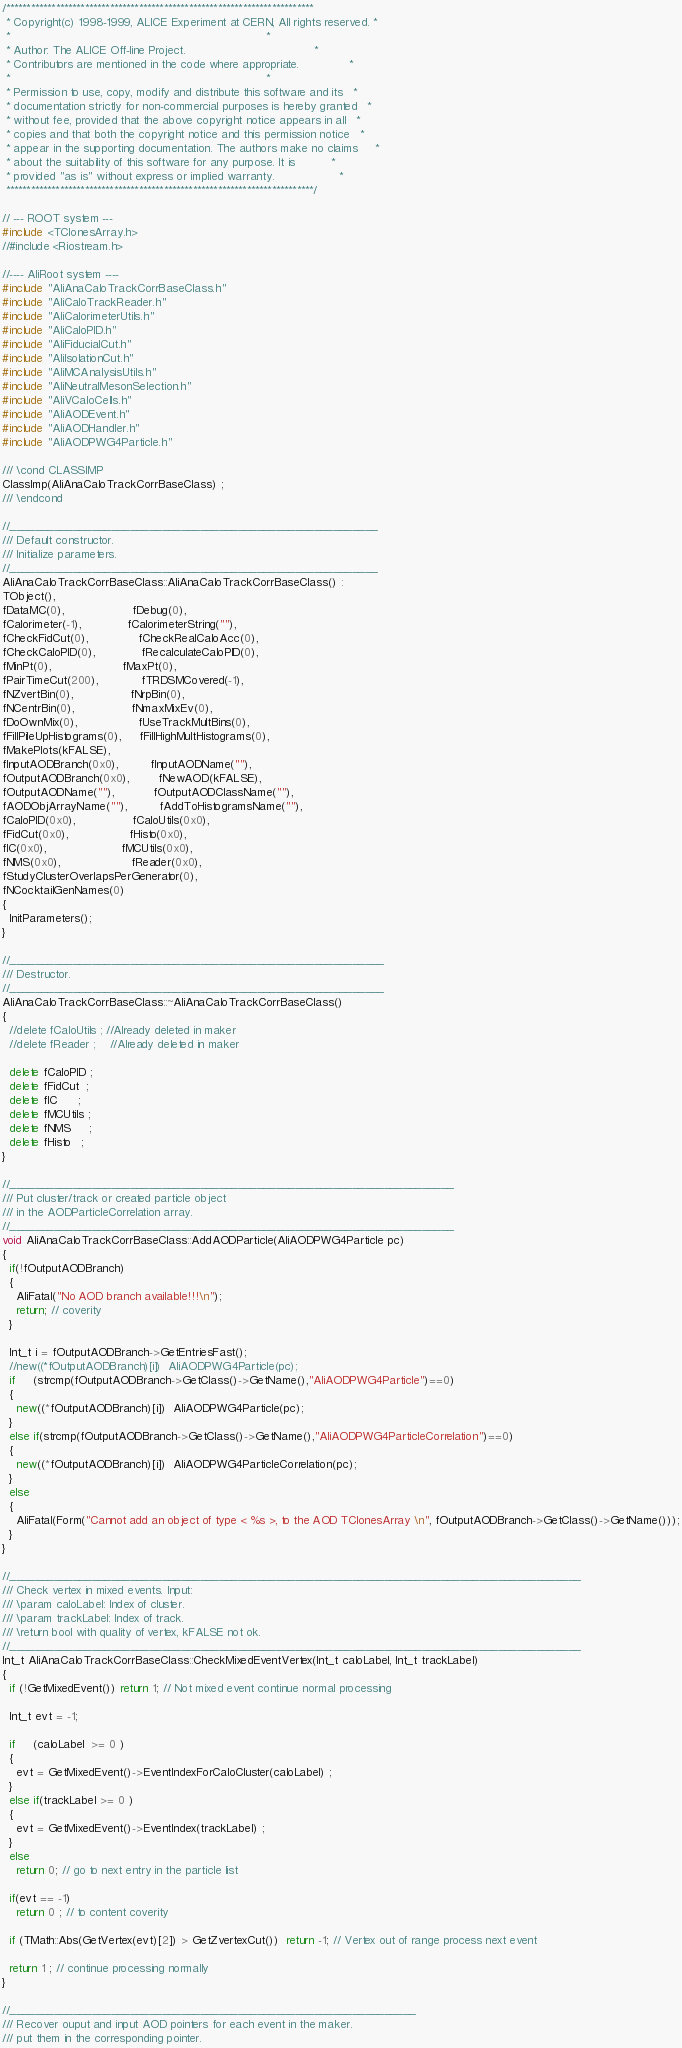Convert code to text. <code><loc_0><loc_0><loc_500><loc_500><_C++_>/**************************************************************************
 * Copyright(c) 1998-1999, ALICE Experiment at CERN, All rights reserved. *
 *                                                                        *
 * Author: The ALICE Off-line Project.                                    *
 * Contributors are mentioned in the code where appropriate.              *
 *                                                                        *
 * Permission to use, copy, modify and distribute this software and its   *
 * documentation strictly for non-commercial purposes is hereby granted   *
 * without fee, provided that the above copyright notice appears in all   *
 * copies and that both the copyright notice and this permission notice   *
 * appear in the supporting documentation. The authors make no claims     *
 * about the suitability of this software for any purpose. It is          *
 * provided "as is" without express or implied warranty.                  *
 **************************************************************************/

// --- ROOT system ---
#include <TClonesArray.h>
//#include <Riostream.h>

//---- AliRoot system ----
#include "AliAnaCaloTrackCorrBaseClass.h"
#include "AliCaloTrackReader.h"
#include "AliCalorimeterUtils.h"
#include "AliCaloPID.h"
#include "AliFiducialCut.h"
#include "AliIsolationCut.h"
#include "AliMCAnalysisUtils.h"
#include "AliNeutralMesonSelection.h"
#include "AliVCaloCells.h" 
#include "AliAODEvent.h"
#include "AliAODHandler.h"
#include "AliAODPWG4Particle.h"

/// \cond CLASSIMP
ClassImp(AliAnaCaloTrackCorrBaseClass) ;
/// \endcond

//__________________________________________________________
/// Default constructor.
/// Initialize parameters.
//__________________________________________________________
AliAnaCaloTrackCorrBaseClass::AliAnaCaloTrackCorrBaseClass() : 
TObject(), 
fDataMC(0),                   fDebug(0),
fCalorimeter(-1),             fCalorimeterString(""),
fCheckFidCut(0),              fCheckRealCaloAcc(0),
fCheckCaloPID(0),             fRecalculateCaloPID(0), 
fMinPt(0),                    fMaxPt(0),
fPairTimeCut(200),            fTRDSMCovered(-1),
fNZvertBin(0),                fNrpBin(0),
fNCentrBin(0),                fNmaxMixEv(0),
fDoOwnMix(0),                 fUseTrackMultBins(0),
fFillPileUpHistograms(0),     fFillHighMultHistograms(0),
fMakePlots(kFALSE),
fInputAODBranch(0x0),         fInputAODName(""),
fOutputAODBranch(0x0),        fNewAOD(kFALSE),
fOutputAODName(""),           fOutputAODClassName(""),
fAODObjArrayName(""),         fAddToHistogramsName(""),
fCaloPID(0x0),                fCaloUtils(0x0),
fFidCut(0x0),                 fHisto(0x0),
fIC(0x0),                     fMCUtils(0x0),                
fNMS(0x0),                    fReader(0x0),
fStudyClusterOverlapsPerGenerator(0),
fNCocktailGenNames(0)
{
  InitParameters();
}

//___________________________________________________________
/// Destructor.
//___________________________________________________________
AliAnaCaloTrackCorrBaseClass::~AliAnaCaloTrackCorrBaseClass() 
{  
  //delete fCaloUtils ; //Already deleted in maker
  //delete fReader ;    //Already deleted in maker
	
  delete fCaloPID ; 
  delete fFidCut  ;  
  delete fIC      ;      
  delete fMCUtils ; 
  delete fNMS     ;     
  delete fHisto   ;    
}

//______________________________________________________________________
/// Put cluster/track or created particle object
/// in the AODParticleCorrelation array.
//______________________________________________________________________
void AliAnaCaloTrackCorrBaseClass::AddAODParticle(AliAODPWG4Particle pc)
{  
  if(!fOutputAODBranch)
  {
    AliFatal("No AOD branch available!!!\n");
    return; // coverity
  }
  
  Int_t i = fOutputAODBranch->GetEntriesFast();
  //new((*fOutputAODBranch)[i])  AliAODPWG4Particle(pc);
  if     (strcmp(fOutputAODBranch->GetClass()->GetName(),"AliAODPWG4Particle")==0)
  {
    new((*fOutputAODBranch)[i])  AliAODPWG4Particle(pc);
  }
  else if(strcmp(fOutputAODBranch->GetClass()->GetName(),"AliAODPWG4ParticleCorrelation")==0)
  {
    new((*fOutputAODBranch)[i])  AliAODPWG4ParticleCorrelation(pc);
  }
  else
  {
    AliFatal(Form("Cannot add an object of type < %s >, to the AOD TClonesArray \n", fOutputAODBranch->GetClass()->GetName()));
  }
}

//__________________________________________________________________________________________
/// Check vertex in mixed events. Input:
/// \param caloLabel: Index of cluster.
/// \param trackLabel: Index of track.
/// \return bool with quality of vertex, kFALSE not ok.
//__________________________________________________________________________________________
Int_t AliAnaCaloTrackCorrBaseClass::CheckMixedEventVertex(Int_t caloLabel, Int_t trackLabel)
{  
  if (!GetMixedEvent()) return 1; // Not mixed event continue normal processing
  
  Int_t evt = -1;
  
  if     (caloLabel  >= 0 )
  {
    evt = GetMixedEvent()->EventIndexForCaloCluster(caloLabel) ;
  }
  else if(trackLabel >= 0 )
  {
    evt = GetMixedEvent()->EventIndex(trackLabel) ;
  }
  else  
    return 0; // go to next entry in the particle list
  
  if(evt == -1) 
    return 0 ; // to content coverity
  
  if (TMath::Abs(GetVertex(evt)[2]) > GetZvertexCut())  return -1; // Vertex out of range process next event
  
  return 1 ; // continue processing normally
}

//________________________________________________________________
/// Recover ouput and input AOD pointers for each event in the maker.
/// put them in the corresponding pointer.</code> 